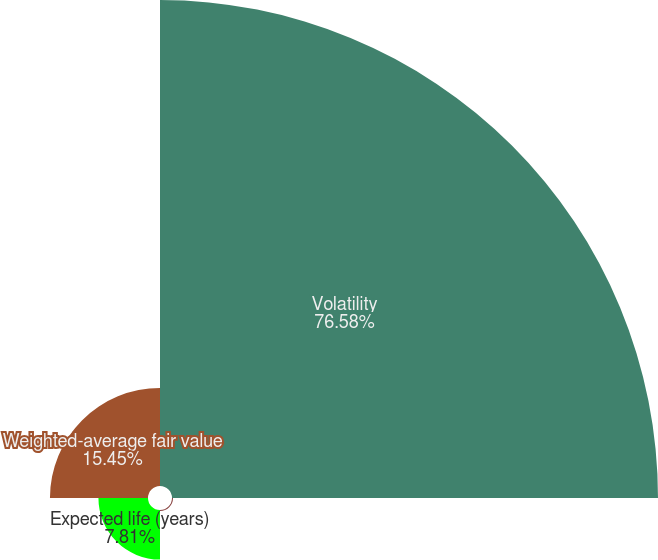Convert chart. <chart><loc_0><loc_0><loc_500><loc_500><pie_chart><fcel>Volatility<fcel>Risk-free interest rate<fcel>Expected life (years)<fcel>Weighted-average fair value<nl><fcel>76.58%<fcel>0.16%<fcel>7.81%<fcel>15.45%<nl></chart> 